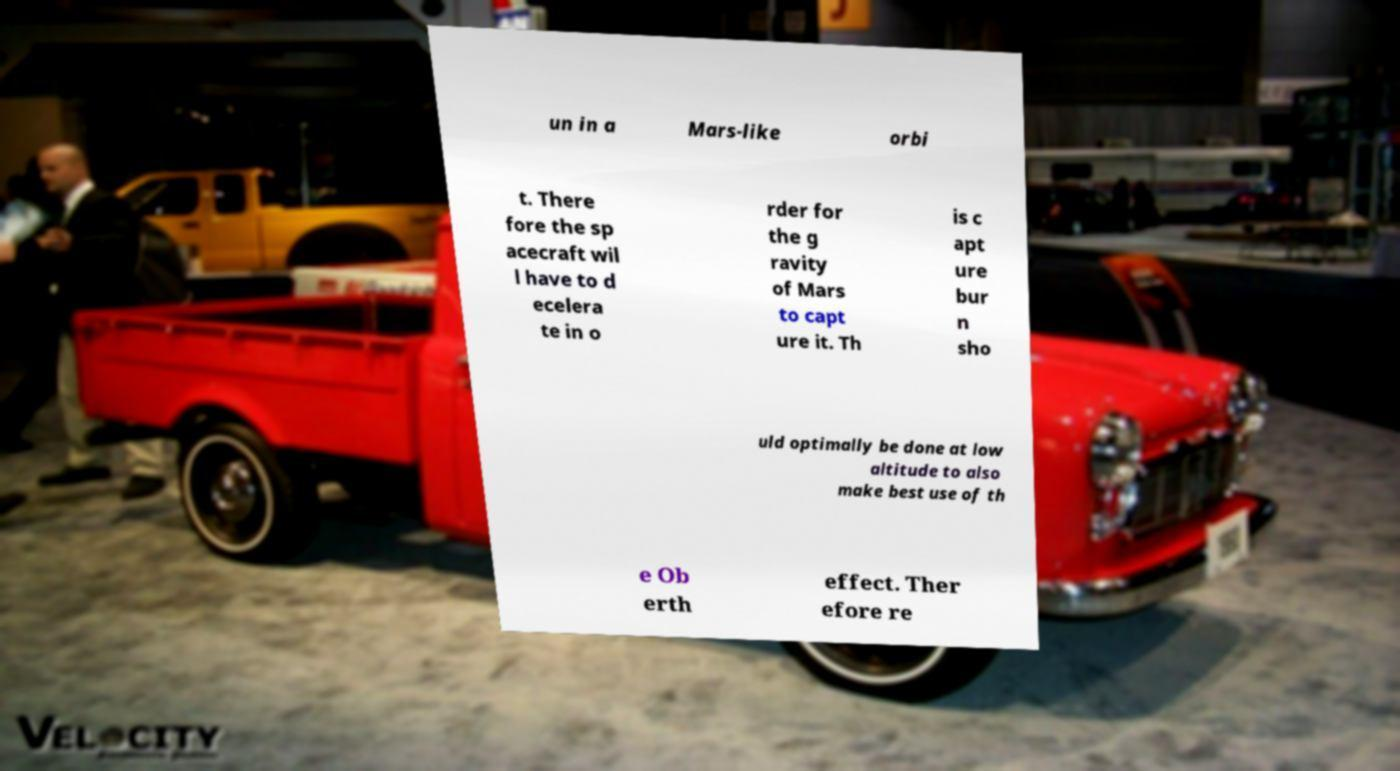Could you assist in decoding the text presented in this image and type it out clearly? un in a Mars-like orbi t. There fore the sp acecraft wil l have to d ecelera te in o rder for the g ravity of Mars to capt ure it. Th is c apt ure bur n sho uld optimally be done at low altitude to also make best use of th e Ob erth effect. Ther efore re 